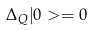Convert formula to latex. <formula><loc_0><loc_0><loc_500><loc_500>\Delta _ { Q } | 0 > = 0</formula> 